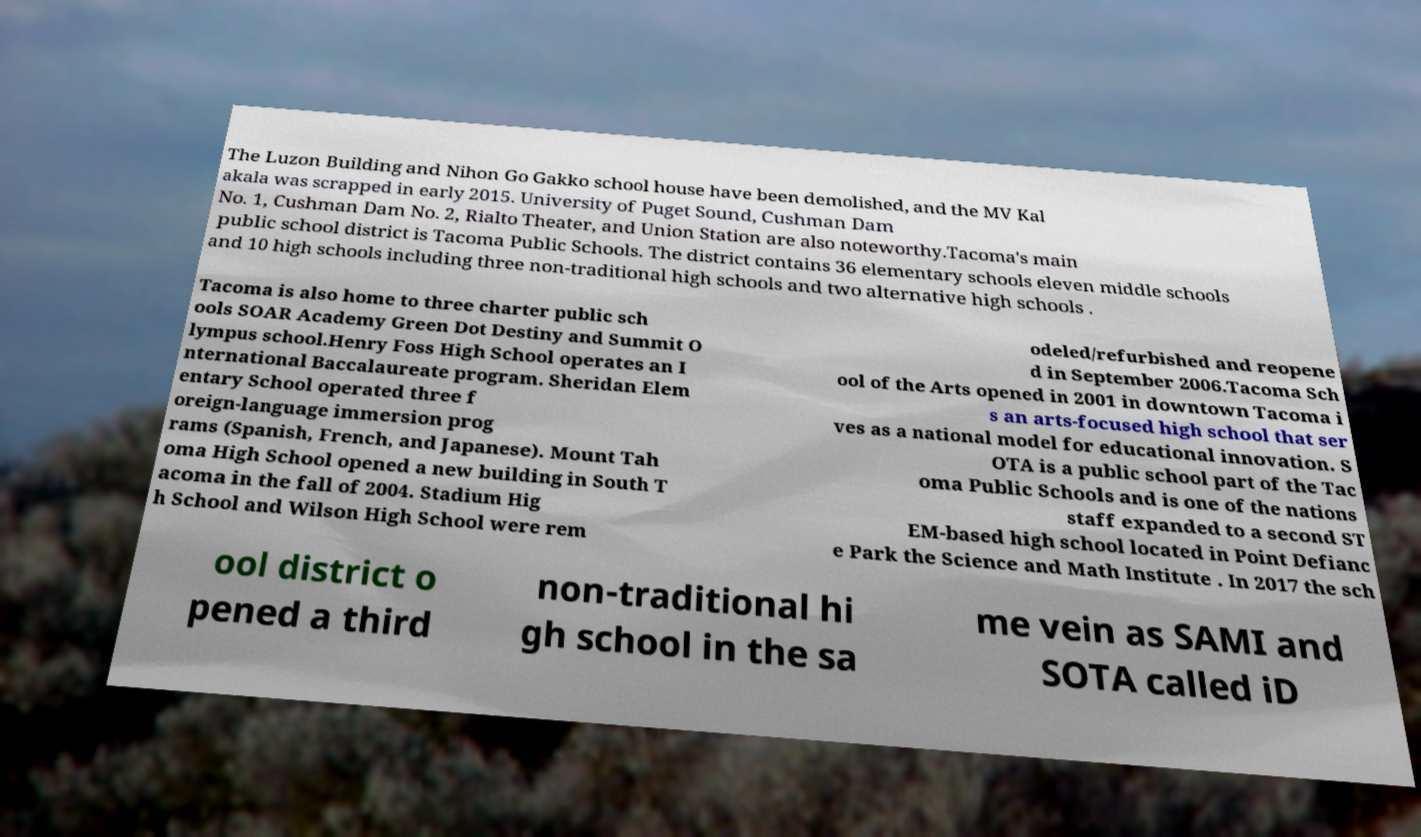Could you assist in decoding the text presented in this image and type it out clearly? The Luzon Building and Nihon Go Gakko school house have been demolished, and the MV Kal akala was scrapped in early 2015. University of Puget Sound, Cushman Dam No. 1, Cushman Dam No. 2, Rialto Theater, and Union Station are also noteworthy.Tacoma's main public school district is Tacoma Public Schools. The district contains 36 elementary schools eleven middle schools and 10 high schools including three non-traditional high schools and two alternative high schools . Tacoma is also home to three charter public sch ools SOAR Academy Green Dot Destiny and Summit O lympus school.Henry Foss High School operates an I nternational Baccalaureate program. Sheridan Elem entary School operated three f oreign-language immersion prog rams (Spanish, French, and Japanese). Mount Tah oma High School opened a new building in South T acoma in the fall of 2004. Stadium Hig h School and Wilson High School were rem odeled/refurbished and reopene d in September 2006.Tacoma Sch ool of the Arts opened in 2001 in downtown Tacoma i s an arts-focused high school that ser ves as a national model for educational innovation. S OTA is a public school part of the Tac oma Public Schools and is one of the nations staff expanded to a second ST EM-based high school located in Point Defianc e Park the Science and Math Institute . In 2017 the sch ool district o pened a third non-traditional hi gh school in the sa me vein as SAMI and SOTA called iD 